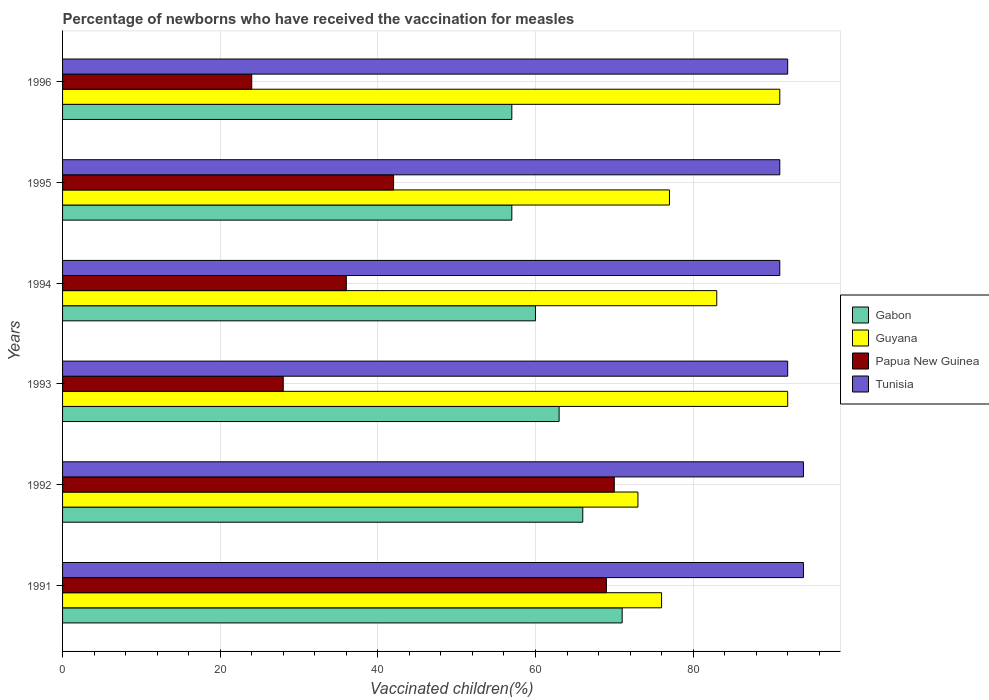How many groups of bars are there?
Your response must be concise. 6. Are the number of bars on each tick of the Y-axis equal?
Your answer should be compact. Yes. What is the percentage of vaccinated children in Tunisia in 1991?
Ensure brevity in your answer.  94. Across all years, what is the maximum percentage of vaccinated children in Tunisia?
Give a very brief answer. 94. In which year was the percentage of vaccinated children in Guyana minimum?
Give a very brief answer. 1992. What is the total percentage of vaccinated children in Gabon in the graph?
Keep it short and to the point. 374. What is the difference between the percentage of vaccinated children in Guyana in 1992 and that in 1996?
Offer a very short reply. -18. What is the average percentage of vaccinated children in Gabon per year?
Your answer should be very brief. 62.33. In the year 1993, what is the difference between the percentage of vaccinated children in Guyana and percentage of vaccinated children in Gabon?
Offer a terse response. 29. What is the ratio of the percentage of vaccinated children in Papua New Guinea in 1991 to that in 1994?
Offer a very short reply. 1.92. Is the percentage of vaccinated children in Tunisia in 1992 less than that in 1993?
Make the answer very short. No. Is the difference between the percentage of vaccinated children in Guyana in 1994 and 1995 greater than the difference between the percentage of vaccinated children in Gabon in 1994 and 1995?
Your answer should be compact. Yes. What is the difference between the highest and the lowest percentage of vaccinated children in Tunisia?
Ensure brevity in your answer.  3. In how many years, is the percentage of vaccinated children in Tunisia greater than the average percentage of vaccinated children in Tunisia taken over all years?
Give a very brief answer. 2. Is it the case that in every year, the sum of the percentage of vaccinated children in Guyana and percentage of vaccinated children in Gabon is greater than the sum of percentage of vaccinated children in Tunisia and percentage of vaccinated children in Papua New Guinea?
Provide a short and direct response. Yes. What does the 3rd bar from the top in 1992 represents?
Offer a terse response. Guyana. What does the 2nd bar from the bottom in 1996 represents?
Ensure brevity in your answer.  Guyana. Is it the case that in every year, the sum of the percentage of vaccinated children in Tunisia and percentage of vaccinated children in Papua New Guinea is greater than the percentage of vaccinated children in Gabon?
Give a very brief answer. Yes. How many bars are there?
Give a very brief answer. 24. Are all the bars in the graph horizontal?
Provide a short and direct response. Yes. Are the values on the major ticks of X-axis written in scientific E-notation?
Offer a terse response. No. Does the graph contain grids?
Make the answer very short. Yes. Where does the legend appear in the graph?
Give a very brief answer. Center right. What is the title of the graph?
Give a very brief answer. Percentage of newborns who have received the vaccination for measles. Does "Estonia" appear as one of the legend labels in the graph?
Your answer should be compact. No. What is the label or title of the X-axis?
Make the answer very short. Vaccinated children(%). What is the label or title of the Y-axis?
Provide a short and direct response. Years. What is the Vaccinated children(%) in Gabon in 1991?
Your answer should be very brief. 71. What is the Vaccinated children(%) in Tunisia in 1991?
Make the answer very short. 94. What is the Vaccinated children(%) in Tunisia in 1992?
Ensure brevity in your answer.  94. What is the Vaccinated children(%) in Guyana in 1993?
Your answer should be compact. 92. What is the Vaccinated children(%) of Tunisia in 1993?
Provide a succinct answer. 92. What is the Vaccinated children(%) in Gabon in 1994?
Your answer should be very brief. 60. What is the Vaccinated children(%) of Tunisia in 1994?
Give a very brief answer. 91. What is the Vaccinated children(%) of Gabon in 1995?
Keep it short and to the point. 57. What is the Vaccinated children(%) of Tunisia in 1995?
Provide a succinct answer. 91. What is the Vaccinated children(%) in Gabon in 1996?
Keep it short and to the point. 57. What is the Vaccinated children(%) in Guyana in 1996?
Offer a very short reply. 91. What is the Vaccinated children(%) of Tunisia in 1996?
Give a very brief answer. 92. Across all years, what is the maximum Vaccinated children(%) in Gabon?
Ensure brevity in your answer.  71. Across all years, what is the maximum Vaccinated children(%) of Guyana?
Your answer should be very brief. 92. Across all years, what is the maximum Vaccinated children(%) in Tunisia?
Ensure brevity in your answer.  94. Across all years, what is the minimum Vaccinated children(%) of Gabon?
Your answer should be very brief. 57. Across all years, what is the minimum Vaccinated children(%) of Tunisia?
Provide a short and direct response. 91. What is the total Vaccinated children(%) of Gabon in the graph?
Give a very brief answer. 374. What is the total Vaccinated children(%) of Guyana in the graph?
Your answer should be compact. 492. What is the total Vaccinated children(%) of Papua New Guinea in the graph?
Provide a succinct answer. 269. What is the total Vaccinated children(%) of Tunisia in the graph?
Provide a short and direct response. 554. What is the difference between the Vaccinated children(%) of Papua New Guinea in 1991 and that in 1992?
Keep it short and to the point. -1. What is the difference between the Vaccinated children(%) of Gabon in 1991 and that in 1993?
Make the answer very short. 8. What is the difference between the Vaccinated children(%) in Guyana in 1991 and that in 1993?
Make the answer very short. -16. What is the difference between the Vaccinated children(%) in Tunisia in 1991 and that in 1993?
Offer a very short reply. 2. What is the difference between the Vaccinated children(%) in Gabon in 1991 and that in 1994?
Give a very brief answer. 11. What is the difference between the Vaccinated children(%) of Guyana in 1991 and that in 1994?
Your answer should be very brief. -7. What is the difference between the Vaccinated children(%) in Tunisia in 1991 and that in 1994?
Make the answer very short. 3. What is the difference between the Vaccinated children(%) of Guyana in 1991 and that in 1995?
Provide a succinct answer. -1. What is the difference between the Vaccinated children(%) of Tunisia in 1991 and that in 1995?
Keep it short and to the point. 3. What is the difference between the Vaccinated children(%) of Guyana in 1991 and that in 1996?
Make the answer very short. -15. What is the difference between the Vaccinated children(%) in Tunisia in 1991 and that in 1996?
Ensure brevity in your answer.  2. What is the difference between the Vaccinated children(%) in Gabon in 1992 and that in 1993?
Your answer should be compact. 3. What is the difference between the Vaccinated children(%) of Papua New Guinea in 1992 and that in 1993?
Your answer should be compact. 42. What is the difference between the Vaccinated children(%) in Tunisia in 1992 and that in 1993?
Your response must be concise. 2. What is the difference between the Vaccinated children(%) in Tunisia in 1992 and that in 1994?
Offer a terse response. 3. What is the difference between the Vaccinated children(%) in Gabon in 1992 and that in 1995?
Ensure brevity in your answer.  9. What is the difference between the Vaccinated children(%) in Guyana in 1992 and that in 1995?
Offer a very short reply. -4. What is the difference between the Vaccinated children(%) of Gabon in 1992 and that in 1996?
Your answer should be compact. 9. What is the difference between the Vaccinated children(%) of Tunisia in 1992 and that in 1996?
Your answer should be compact. 2. What is the difference between the Vaccinated children(%) of Gabon in 1993 and that in 1994?
Your answer should be compact. 3. What is the difference between the Vaccinated children(%) in Guyana in 1993 and that in 1994?
Make the answer very short. 9. What is the difference between the Vaccinated children(%) in Papua New Guinea in 1993 and that in 1994?
Ensure brevity in your answer.  -8. What is the difference between the Vaccinated children(%) of Tunisia in 1993 and that in 1994?
Offer a very short reply. 1. What is the difference between the Vaccinated children(%) in Papua New Guinea in 1993 and that in 1995?
Make the answer very short. -14. What is the difference between the Vaccinated children(%) of Gabon in 1993 and that in 1996?
Your answer should be very brief. 6. What is the difference between the Vaccinated children(%) of Guyana in 1993 and that in 1996?
Make the answer very short. 1. What is the difference between the Vaccinated children(%) of Papua New Guinea in 1993 and that in 1996?
Offer a very short reply. 4. What is the difference between the Vaccinated children(%) of Guyana in 1994 and that in 1995?
Ensure brevity in your answer.  6. What is the difference between the Vaccinated children(%) in Papua New Guinea in 1994 and that in 1995?
Offer a terse response. -6. What is the difference between the Vaccinated children(%) in Tunisia in 1994 and that in 1995?
Make the answer very short. 0. What is the difference between the Vaccinated children(%) in Papua New Guinea in 1995 and that in 1996?
Your answer should be compact. 18. What is the difference between the Vaccinated children(%) of Gabon in 1991 and the Vaccinated children(%) of Papua New Guinea in 1992?
Keep it short and to the point. 1. What is the difference between the Vaccinated children(%) in Gabon in 1991 and the Vaccinated children(%) in Tunisia in 1992?
Offer a very short reply. -23. What is the difference between the Vaccinated children(%) of Gabon in 1991 and the Vaccinated children(%) of Guyana in 1993?
Keep it short and to the point. -21. What is the difference between the Vaccinated children(%) in Gabon in 1991 and the Vaccinated children(%) in Papua New Guinea in 1993?
Give a very brief answer. 43. What is the difference between the Vaccinated children(%) of Gabon in 1991 and the Vaccinated children(%) of Tunisia in 1993?
Provide a succinct answer. -21. What is the difference between the Vaccinated children(%) of Guyana in 1991 and the Vaccinated children(%) of Papua New Guinea in 1993?
Give a very brief answer. 48. What is the difference between the Vaccinated children(%) in Guyana in 1991 and the Vaccinated children(%) in Tunisia in 1993?
Keep it short and to the point. -16. What is the difference between the Vaccinated children(%) of Gabon in 1991 and the Vaccinated children(%) of Papua New Guinea in 1994?
Your response must be concise. 35. What is the difference between the Vaccinated children(%) in Gabon in 1991 and the Vaccinated children(%) in Tunisia in 1994?
Offer a very short reply. -20. What is the difference between the Vaccinated children(%) of Papua New Guinea in 1991 and the Vaccinated children(%) of Tunisia in 1994?
Provide a succinct answer. -22. What is the difference between the Vaccinated children(%) of Gabon in 1991 and the Vaccinated children(%) of Guyana in 1995?
Offer a terse response. -6. What is the difference between the Vaccinated children(%) of Gabon in 1991 and the Vaccinated children(%) of Papua New Guinea in 1995?
Offer a very short reply. 29. What is the difference between the Vaccinated children(%) in Gabon in 1991 and the Vaccinated children(%) in Tunisia in 1995?
Keep it short and to the point. -20. What is the difference between the Vaccinated children(%) in Papua New Guinea in 1991 and the Vaccinated children(%) in Tunisia in 1995?
Your answer should be very brief. -22. What is the difference between the Vaccinated children(%) of Gabon in 1991 and the Vaccinated children(%) of Guyana in 1996?
Provide a succinct answer. -20. What is the difference between the Vaccinated children(%) in Gabon in 1991 and the Vaccinated children(%) in Papua New Guinea in 1996?
Give a very brief answer. 47. What is the difference between the Vaccinated children(%) of Gabon in 1991 and the Vaccinated children(%) of Tunisia in 1996?
Offer a terse response. -21. What is the difference between the Vaccinated children(%) in Guyana in 1991 and the Vaccinated children(%) in Papua New Guinea in 1996?
Your answer should be compact. 52. What is the difference between the Vaccinated children(%) of Gabon in 1992 and the Vaccinated children(%) of Papua New Guinea in 1993?
Give a very brief answer. 38. What is the difference between the Vaccinated children(%) of Guyana in 1992 and the Vaccinated children(%) of Papua New Guinea in 1993?
Make the answer very short. 45. What is the difference between the Vaccinated children(%) of Papua New Guinea in 1992 and the Vaccinated children(%) of Tunisia in 1993?
Give a very brief answer. -22. What is the difference between the Vaccinated children(%) in Gabon in 1992 and the Vaccinated children(%) in Guyana in 1994?
Offer a terse response. -17. What is the difference between the Vaccinated children(%) in Gabon in 1992 and the Vaccinated children(%) in Guyana in 1995?
Offer a very short reply. -11. What is the difference between the Vaccinated children(%) in Guyana in 1992 and the Vaccinated children(%) in Tunisia in 1995?
Keep it short and to the point. -18. What is the difference between the Vaccinated children(%) in Papua New Guinea in 1992 and the Vaccinated children(%) in Tunisia in 1995?
Provide a succinct answer. -21. What is the difference between the Vaccinated children(%) of Gabon in 1993 and the Vaccinated children(%) of Guyana in 1994?
Your answer should be compact. -20. What is the difference between the Vaccinated children(%) in Guyana in 1993 and the Vaccinated children(%) in Papua New Guinea in 1994?
Provide a short and direct response. 56. What is the difference between the Vaccinated children(%) in Guyana in 1993 and the Vaccinated children(%) in Tunisia in 1994?
Offer a terse response. 1. What is the difference between the Vaccinated children(%) in Papua New Guinea in 1993 and the Vaccinated children(%) in Tunisia in 1994?
Offer a terse response. -63. What is the difference between the Vaccinated children(%) of Gabon in 1993 and the Vaccinated children(%) of Guyana in 1995?
Offer a very short reply. -14. What is the difference between the Vaccinated children(%) in Gabon in 1993 and the Vaccinated children(%) in Tunisia in 1995?
Keep it short and to the point. -28. What is the difference between the Vaccinated children(%) of Guyana in 1993 and the Vaccinated children(%) of Papua New Guinea in 1995?
Keep it short and to the point. 50. What is the difference between the Vaccinated children(%) of Guyana in 1993 and the Vaccinated children(%) of Tunisia in 1995?
Make the answer very short. 1. What is the difference between the Vaccinated children(%) of Papua New Guinea in 1993 and the Vaccinated children(%) of Tunisia in 1995?
Offer a terse response. -63. What is the difference between the Vaccinated children(%) of Gabon in 1993 and the Vaccinated children(%) of Guyana in 1996?
Your answer should be very brief. -28. What is the difference between the Vaccinated children(%) in Gabon in 1993 and the Vaccinated children(%) in Tunisia in 1996?
Give a very brief answer. -29. What is the difference between the Vaccinated children(%) in Guyana in 1993 and the Vaccinated children(%) in Papua New Guinea in 1996?
Offer a terse response. 68. What is the difference between the Vaccinated children(%) in Papua New Guinea in 1993 and the Vaccinated children(%) in Tunisia in 1996?
Make the answer very short. -64. What is the difference between the Vaccinated children(%) in Gabon in 1994 and the Vaccinated children(%) in Guyana in 1995?
Your answer should be compact. -17. What is the difference between the Vaccinated children(%) of Gabon in 1994 and the Vaccinated children(%) of Papua New Guinea in 1995?
Give a very brief answer. 18. What is the difference between the Vaccinated children(%) of Gabon in 1994 and the Vaccinated children(%) of Tunisia in 1995?
Give a very brief answer. -31. What is the difference between the Vaccinated children(%) in Papua New Guinea in 1994 and the Vaccinated children(%) in Tunisia in 1995?
Offer a terse response. -55. What is the difference between the Vaccinated children(%) in Gabon in 1994 and the Vaccinated children(%) in Guyana in 1996?
Make the answer very short. -31. What is the difference between the Vaccinated children(%) in Gabon in 1994 and the Vaccinated children(%) in Tunisia in 1996?
Ensure brevity in your answer.  -32. What is the difference between the Vaccinated children(%) in Guyana in 1994 and the Vaccinated children(%) in Papua New Guinea in 1996?
Ensure brevity in your answer.  59. What is the difference between the Vaccinated children(%) of Guyana in 1994 and the Vaccinated children(%) of Tunisia in 1996?
Offer a very short reply. -9. What is the difference between the Vaccinated children(%) of Papua New Guinea in 1994 and the Vaccinated children(%) of Tunisia in 1996?
Offer a very short reply. -56. What is the difference between the Vaccinated children(%) of Gabon in 1995 and the Vaccinated children(%) of Guyana in 1996?
Give a very brief answer. -34. What is the difference between the Vaccinated children(%) in Gabon in 1995 and the Vaccinated children(%) in Papua New Guinea in 1996?
Offer a very short reply. 33. What is the difference between the Vaccinated children(%) of Gabon in 1995 and the Vaccinated children(%) of Tunisia in 1996?
Provide a succinct answer. -35. What is the difference between the Vaccinated children(%) in Guyana in 1995 and the Vaccinated children(%) in Papua New Guinea in 1996?
Offer a very short reply. 53. What is the difference between the Vaccinated children(%) of Guyana in 1995 and the Vaccinated children(%) of Tunisia in 1996?
Your answer should be very brief. -15. What is the difference between the Vaccinated children(%) of Papua New Guinea in 1995 and the Vaccinated children(%) of Tunisia in 1996?
Your answer should be very brief. -50. What is the average Vaccinated children(%) in Gabon per year?
Provide a succinct answer. 62.33. What is the average Vaccinated children(%) in Papua New Guinea per year?
Provide a succinct answer. 44.83. What is the average Vaccinated children(%) of Tunisia per year?
Your answer should be very brief. 92.33. In the year 1991, what is the difference between the Vaccinated children(%) of Gabon and Vaccinated children(%) of Guyana?
Provide a short and direct response. -5. In the year 1991, what is the difference between the Vaccinated children(%) of Guyana and Vaccinated children(%) of Papua New Guinea?
Keep it short and to the point. 7. In the year 1991, what is the difference between the Vaccinated children(%) in Guyana and Vaccinated children(%) in Tunisia?
Your answer should be compact. -18. In the year 1991, what is the difference between the Vaccinated children(%) in Papua New Guinea and Vaccinated children(%) in Tunisia?
Your response must be concise. -25. In the year 1992, what is the difference between the Vaccinated children(%) of Gabon and Vaccinated children(%) of Papua New Guinea?
Provide a succinct answer. -4. In the year 1993, what is the difference between the Vaccinated children(%) of Gabon and Vaccinated children(%) of Tunisia?
Give a very brief answer. -29. In the year 1993, what is the difference between the Vaccinated children(%) in Guyana and Vaccinated children(%) in Papua New Guinea?
Your answer should be compact. 64. In the year 1993, what is the difference between the Vaccinated children(%) in Guyana and Vaccinated children(%) in Tunisia?
Your response must be concise. 0. In the year 1993, what is the difference between the Vaccinated children(%) of Papua New Guinea and Vaccinated children(%) of Tunisia?
Provide a short and direct response. -64. In the year 1994, what is the difference between the Vaccinated children(%) in Gabon and Vaccinated children(%) in Tunisia?
Offer a very short reply. -31. In the year 1994, what is the difference between the Vaccinated children(%) of Guyana and Vaccinated children(%) of Papua New Guinea?
Offer a very short reply. 47. In the year 1994, what is the difference between the Vaccinated children(%) in Papua New Guinea and Vaccinated children(%) in Tunisia?
Give a very brief answer. -55. In the year 1995, what is the difference between the Vaccinated children(%) in Gabon and Vaccinated children(%) in Papua New Guinea?
Keep it short and to the point. 15. In the year 1995, what is the difference between the Vaccinated children(%) in Gabon and Vaccinated children(%) in Tunisia?
Your answer should be compact. -34. In the year 1995, what is the difference between the Vaccinated children(%) in Guyana and Vaccinated children(%) in Tunisia?
Make the answer very short. -14. In the year 1995, what is the difference between the Vaccinated children(%) of Papua New Guinea and Vaccinated children(%) of Tunisia?
Provide a succinct answer. -49. In the year 1996, what is the difference between the Vaccinated children(%) in Gabon and Vaccinated children(%) in Guyana?
Your answer should be compact. -34. In the year 1996, what is the difference between the Vaccinated children(%) in Gabon and Vaccinated children(%) in Papua New Guinea?
Your response must be concise. 33. In the year 1996, what is the difference between the Vaccinated children(%) in Gabon and Vaccinated children(%) in Tunisia?
Offer a terse response. -35. In the year 1996, what is the difference between the Vaccinated children(%) of Guyana and Vaccinated children(%) of Tunisia?
Your answer should be compact. -1. In the year 1996, what is the difference between the Vaccinated children(%) in Papua New Guinea and Vaccinated children(%) in Tunisia?
Your answer should be compact. -68. What is the ratio of the Vaccinated children(%) of Gabon in 1991 to that in 1992?
Provide a succinct answer. 1.08. What is the ratio of the Vaccinated children(%) in Guyana in 1991 to that in 1992?
Offer a very short reply. 1.04. What is the ratio of the Vaccinated children(%) in Papua New Guinea in 1991 to that in 1992?
Offer a terse response. 0.99. What is the ratio of the Vaccinated children(%) in Gabon in 1991 to that in 1993?
Keep it short and to the point. 1.13. What is the ratio of the Vaccinated children(%) of Guyana in 1991 to that in 1993?
Offer a very short reply. 0.83. What is the ratio of the Vaccinated children(%) of Papua New Guinea in 1991 to that in 1993?
Your answer should be compact. 2.46. What is the ratio of the Vaccinated children(%) of Tunisia in 1991 to that in 1993?
Your response must be concise. 1.02. What is the ratio of the Vaccinated children(%) in Gabon in 1991 to that in 1994?
Provide a succinct answer. 1.18. What is the ratio of the Vaccinated children(%) of Guyana in 1991 to that in 1994?
Make the answer very short. 0.92. What is the ratio of the Vaccinated children(%) in Papua New Guinea in 1991 to that in 1994?
Your response must be concise. 1.92. What is the ratio of the Vaccinated children(%) of Tunisia in 1991 to that in 1994?
Keep it short and to the point. 1.03. What is the ratio of the Vaccinated children(%) of Gabon in 1991 to that in 1995?
Offer a terse response. 1.25. What is the ratio of the Vaccinated children(%) in Papua New Guinea in 1991 to that in 1995?
Your response must be concise. 1.64. What is the ratio of the Vaccinated children(%) of Tunisia in 1991 to that in 1995?
Provide a succinct answer. 1.03. What is the ratio of the Vaccinated children(%) in Gabon in 1991 to that in 1996?
Provide a succinct answer. 1.25. What is the ratio of the Vaccinated children(%) of Guyana in 1991 to that in 1996?
Offer a terse response. 0.84. What is the ratio of the Vaccinated children(%) in Papua New Guinea in 1991 to that in 1996?
Offer a terse response. 2.88. What is the ratio of the Vaccinated children(%) of Tunisia in 1991 to that in 1996?
Offer a very short reply. 1.02. What is the ratio of the Vaccinated children(%) in Gabon in 1992 to that in 1993?
Keep it short and to the point. 1.05. What is the ratio of the Vaccinated children(%) in Guyana in 1992 to that in 1993?
Make the answer very short. 0.79. What is the ratio of the Vaccinated children(%) of Papua New Guinea in 1992 to that in 1993?
Ensure brevity in your answer.  2.5. What is the ratio of the Vaccinated children(%) in Tunisia in 1992 to that in 1993?
Ensure brevity in your answer.  1.02. What is the ratio of the Vaccinated children(%) of Gabon in 1992 to that in 1994?
Your answer should be very brief. 1.1. What is the ratio of the Vaccinated children(%) of Guyana in 1992 to that in 1994?
Give a very brief answer. 0.88. What is the ratio of the Vaccinated children(%) of Papua New Guinea in 1992 to that in 1994?
Ensure brevity in your answer.  1.94. What is the ratio of the Vaccinated children(%) of Tunisia in 1992 to that in 1994?
Offer a terse response. 1.03. What is the ratio of the Vaccinated children(%) in Gabon in 1992 to that in 1995?
Provide a short and direct response. 1.16. What is the ratio of the Vaccinated children(%) of Guyana in 1992 to that in 1995?
Ensure brevity in your answer.  0.95. What is the ratio of the Vaccinated children(%) in Papua New Guinea in 1992 to that in 1995?
Your answer should be very brief. 1.67. What is the ratio of the Vaccinated children(%) of Tunisia in 1992 to that in 1995?
Offer a very short reply. 1.03. What is the ratio of the Vaccinated children(%) in Gabon in 1992 to that in 1996?
Offer a terse response. 1.16. What is the ratio of the Vaccinated children(%) in Guyana in 1992 to that in 1996?
Your response must be concise. 0.8. What is the ratio of the Vaccinated children(%) of Papua New Guinea in 1992 to that in 1996?
Provide a short and direct response. 2.92. What is the ratio of the Vaccinated children(%) in Tunisia in 1992 to that in 1996?
Give a very brief answer. 1.02. What is the ratio of the Vaccinated children(%) of Gabon in 1993 to that in 1994?
Provide a short and direct response. 1.05. What is the ratio of the Vaccinated children(%) of Guyana in 1993 to that in 1994?
Provide a succinct answer. 1.11. What is the ratio of the Vaccinated children(%) in Gabon in 1993 to that in 1995?
Your answer should be very brief. 1.11. What is the ratio of the Vaccinated children(%) in Guyana in 1993 to that in 1995?
Provide a succinct answer. 1.19. What is the ratio of the Vaccinated children(%) of Tunisia in 1993 to that in 1995?
Offer a terse response. 1.01. What is the ratio of the Vaccinated children(%) in Gabon in 1993 to that in 1996?
Give a very brief answer. 1.11. What is the ratio of the Vaccinated children(%) of Tunisia in 1993 to that in 1996?
Keep it short and to the point. 1. What is the ratio of the Vaccinated children(%) in Gabon in 1994 to that in 1995?
Give a very brief answer. 1.05. What is the ratio of the Vaccinated children(%) of Guyana in 1994 to that in 1995?
Offer a terse response. 1.08. What is the ratio of the Vaccinated children(%) in Tunisia in 1994 to that in 1995?
Give a very brief answer. 1. What is the ratio of the Vaccinated children(%) of Gabon in 1994 to that in 1996?
Your answer should be compact. 1.05. What is the ratio of the Vaccinated children(%) in Guyana in 1994 to that in 1996?
Your response must be concise. 0.91. What is the ratio of the Vaccinated children(%) of Tunisia in 1994 to that in 1996?
Give a very brief answer. 0.99. What is the ratio of the Vaccinated children(%) of Gabon in 1995 to that in 1996?
Provide a short and direct response. 1. What is the ratio of the Vaccinated children(%) of Guyana in 1995 to that in 1996?
Provide a succinct answer. 0.85. What is the ratio of the Vaccinated children(%) in Tunisia in 1995 to that in 1996?
Keep it short and to the point. 0.99. What is the difference between the highest and the second highest Vaccinated children(%) of Papua New Guinea?
Provide a succinct answer. 1. What is the difference between the highest and the second highest Vaccinated children(%) of Tunisia?
Your answer should be compact. 0. What is the difference between the highest and the lowest Vaccinated children(%) in Gabon?
Make the answer very short. 14. What is the difference between the highest and the lowest Vaccinated children(%) in Papua New Guinea?
Ensure brevity in your answer.  46. What is the difference between the highest and the lowest Vaccinated children(%) in Tunisia?
Your answer should be compact. 3. 